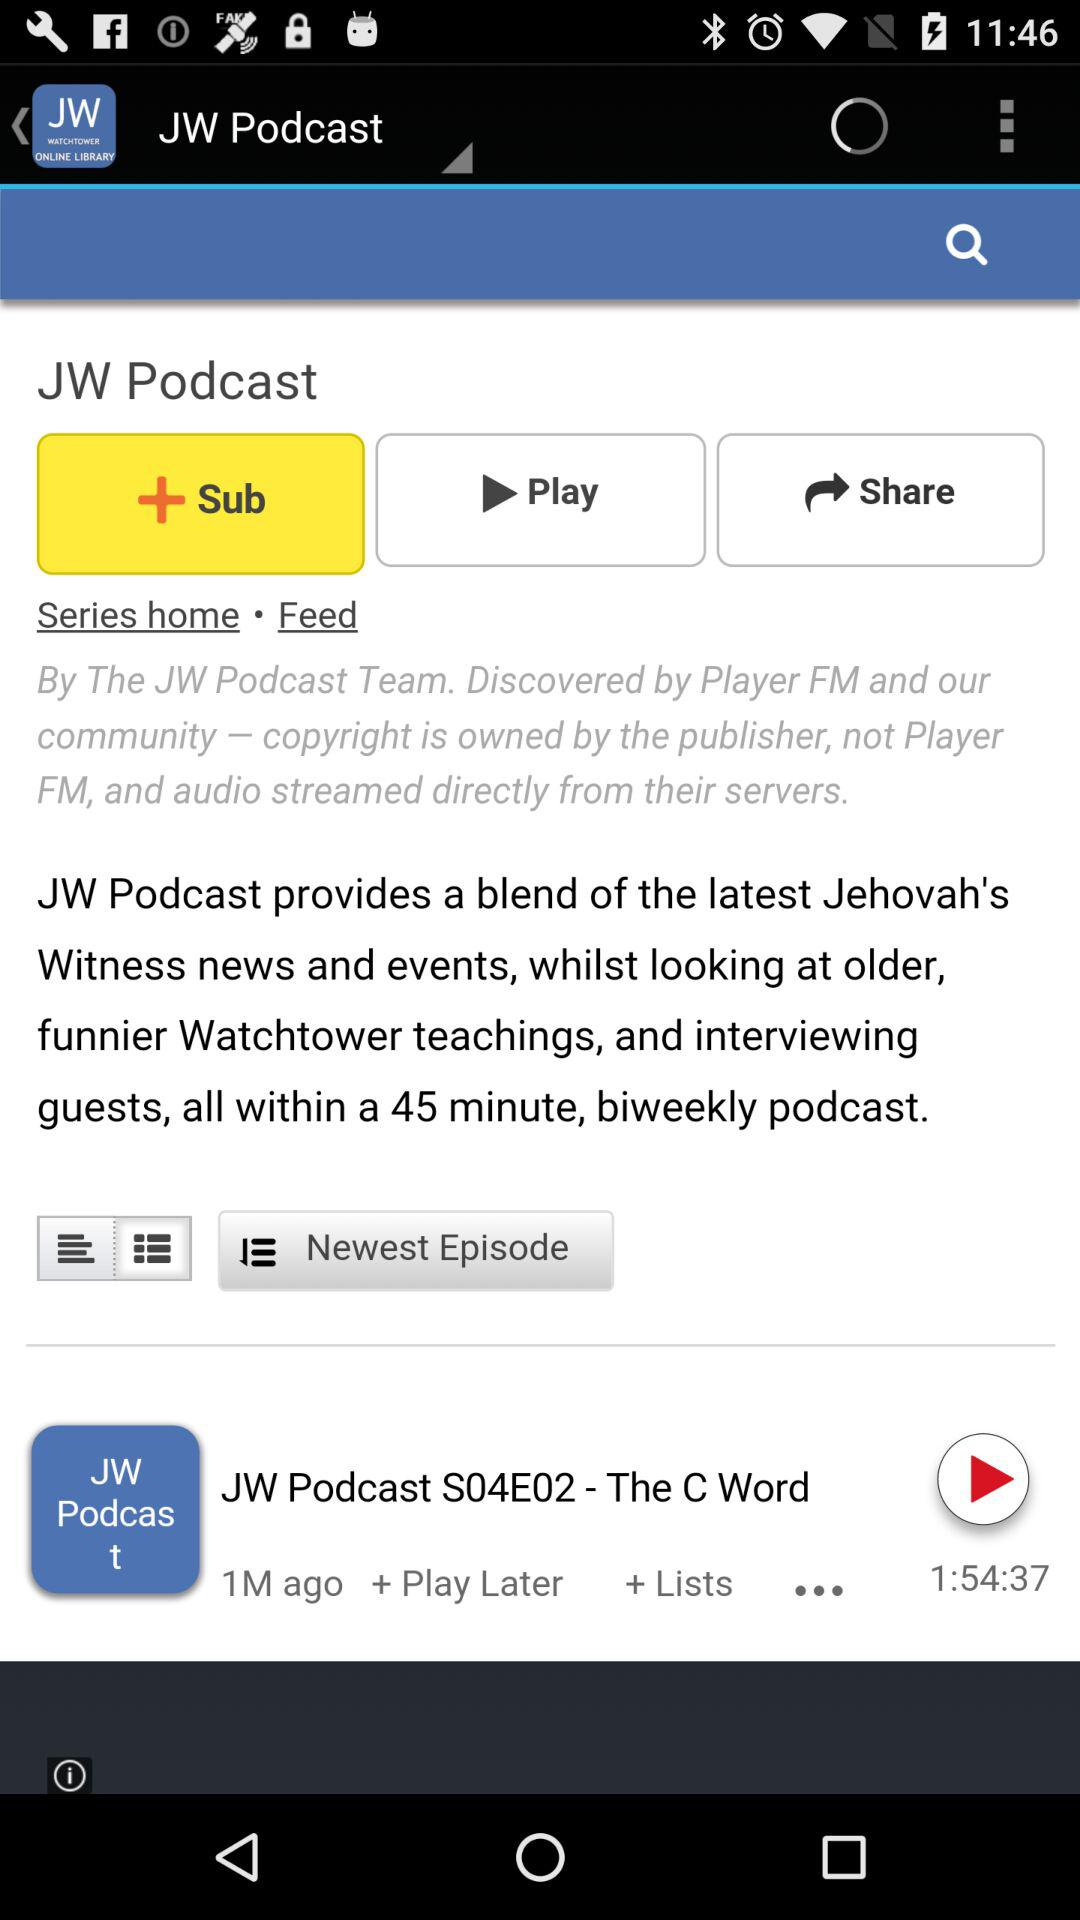What is the time duration? The time duration is 1 hour, 54 minutes and 37 seconds. 